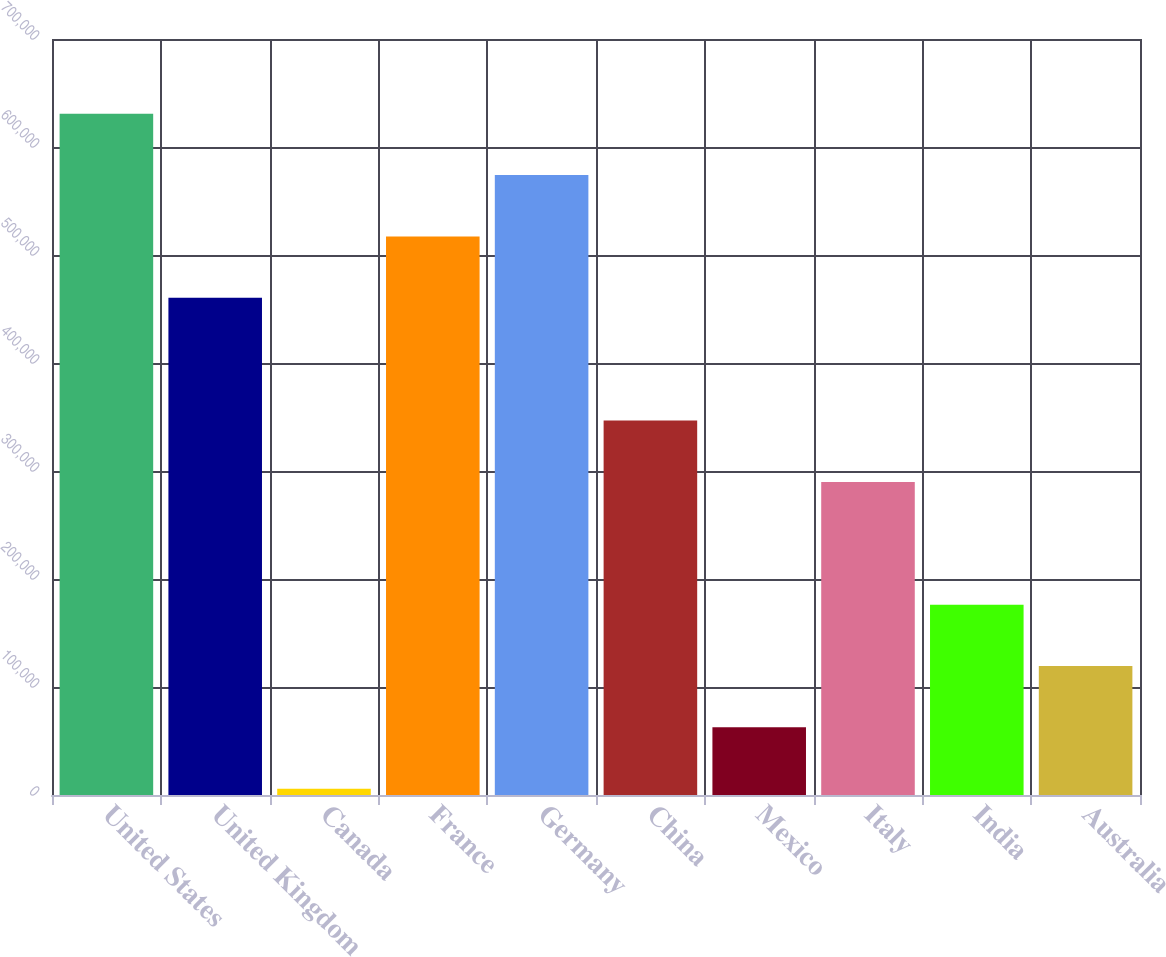Convert chart to OTSL. <chart><loc_0><loc_0><loc_500><loc_500><bar_chart><fcel>United States<fcel>United Kingdom<fcel>Canada<fcel>France<fcel>Germany<fcel>China<fcel>Mexico<fcel>Italy<fcel>India<fcel>Australia<nl><fcel>630787<fcel>460342<fcel>5822<fcel>517157<fcel>573972<fcel>346712<fcel>62637<fcel>289897<fcel>176267<fcel>119452<nl></chart> 